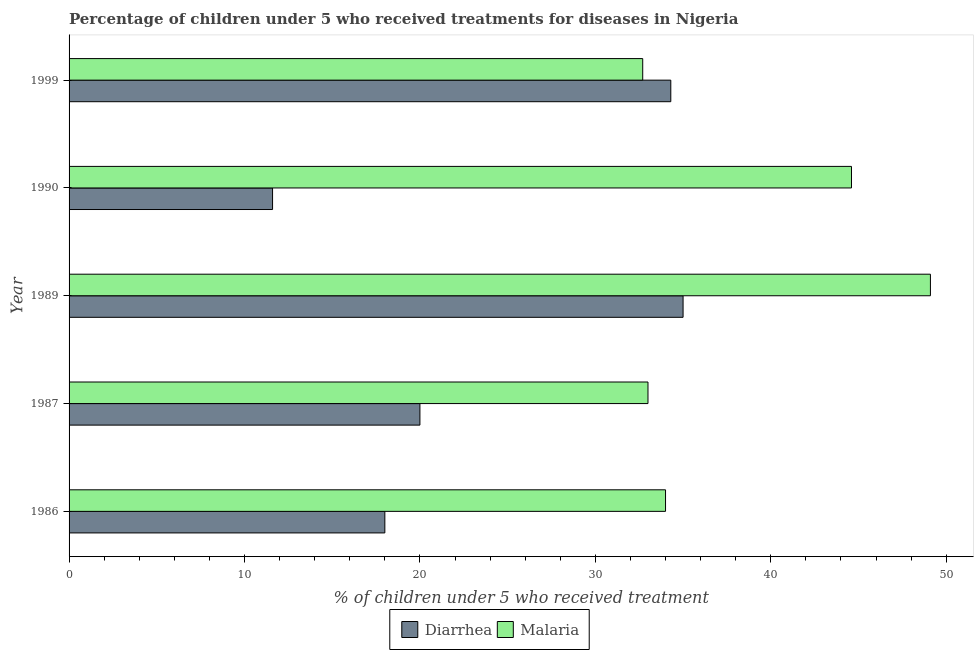How many groups of bars are there?
Provide a short and direct response. 5. How many bars are there on the 5th tick from the top?
Provide a short and direct response. 2. How many bars are there on the 2nd tick from the bottom?
Make the answer very short. 2. What is the label of the 1st group of bars from the top?
Make the answer very short. 1999. What is the percentage of children who received treatment for malaria in 1990?
Your response must be concise. 44.6. Across all years, what is the maximum percentage of children who received treatment for malaria?
Your response must be concise. 49.1. In which year was the percentage of children who received treatment for malaria maximum?
Keep it short and to the point. 1989. What is the total percentage of children who received treatment for malaria in the graph?
Your answer should be compact. 193.4. What is the difference between the percentage of children who received treatment for malaria in 1986 and that in 1989?
Your response must be concise. -15.1. What is the average percentage of children who received treatment for diarrhoea per year?
Your response must be concise. 23.78. In the year 1989, what is the difference between the percentage of children who received treatment for malaria and percentage of children who received treatment for diarrhoea?
Give a very brief answer. 14.1. Is the percentage of children who received treatment for diarrhoea in 1990 less than that in 1999?
Ensure brevity in your answer.  Yes. In how many years, is the percentage of children who received treatment for malaria greater than the average percentage of children who received treatment for malaria taken over all years?
Provide a succinct answer. 2. What does the 1st bar from the top in 1990 represents?
Your answer should be very brief. Malaria. What does the 1st bar from the bottom in 1990 represents?
Your answer should be compact. Diarrhea. Are all the bars in the graph horizontal?
Provide a short and direct response. Yes. Are the values on the major ticks of X-axis written in scientific E-notation?
Keep it short and to the point. No. Does the graph contain grids?
Your answer should be compact. No. How are the legend labels stacked?
Your response must be concise. Horizontal. What is the title of the graph?
Make the answer very short. Percentage of children under 5 who received treatments for diseases in Nigeria. Does "Fertility rate" appear as one of the legend labels in the graph?
Offer a very short reply. No. What is the label or title of the X-axis?
Provide a succinct answer. % of children under 5 who received treatment. What is the label or title of the Y-axis?
Offer a very short reply. Year. What is the % of children under 5 who received treatment of Malaria in 1986?
Your answer should be compact. 34. What is the % of children under 5 who received treatment of Diarrhea in 1989?
Ensure brevity in your answer.  35. What is the % of children under 5 who received treatment of Malaria in 1989?
Keep it short and to the point. 49.1. What is the % of children under 5 who received treatment in Malaria in 1990?
Ensure brevity in your answer.  44.6. What is the % of children under 5 who received treatment in Diarrhea in 1999?
Provide a short and direct response. 34.3. What is the % of children under 5 who received treatment of Malaria in 1999?
Provide a succinct answer. 32.7. Across all years, what is the maximum % of children under 5 who received treatment in Diarrhea?
Offer a terse response. 35. Across all years, what is the maximum % of children under 5 who received treatment of Malaria?
Provide a short and direct response. 49.1. Across all years, what is the minimum % of children under 5 who received treatment in Malaria?
Ensure brevity in your answer.  32.7. What is the total % of children under 5 who received treatment of Diarrhea in the graph?
Make the answer very short. 118.9. What is the total % of children under 5 who received treatment in Malaria in the graph?
Your response must be concise. 193.4. What is the difference between the % of children under 5 who received treatment in Malaria in 1986 and that in 1987?
Provide a succinct answer. 1. What is the difference between the % of children under 5 who received treatment in Malaria in 1986 and that in 1989?
Offer a terse response. -15.1. What is the difference between the % of children under 5 who received treatment in Diarrhea in 1986 and that in 1990?
Offer a terse response. 6.4. What is the difference between the % of children under 5 who received treatment in Malaria in 1986 and that in 1990?
Your answer should be compact. -10.6. What is the difference between the % of children under 5 who received treatment in Diarrhea in 1986 and that in 1999?
Ensure brevity in your answer.  -16.3. What is the difference between the % of children under 5 who received treatment of Malaria in 1986 and that in 1999?
Provide a succinct answer. 1.3. What is the difference between the % of children under 5 who received treatment of Malaria in 1987 and that in 1989?
Your answer should be very brief. -16.1. What is the difference between the % of children under 5 who received treatment of Diarrhea in 1987 and that in 1990?
Ensure brevity in your answer.  8.4. What is the difference between the % of children under 5 who received treatment in Diarrhea in 1987 and that in 1999?
Provide a succinct answer. -14.3. What is the difference between the % of children under 5 who received treatment in Malaria in 1987 and that in 1999?
Provide a succinct answer. 0.3. What is the difference between the % of children under 5 who received treatment of Diarrhea in 1989 and that in 1990?
Keep it short and to the point. 23.4. What is the difference between the % of children under 5 who received treatment in Malaria in 1989 and that in 1990?
Keep it short and to the point. 4.5. What is the difference between the % of children under 5 who received treatment in Diarrhea in 1989 and that in 1999?
Keep it short and to the point. 0.7. What is the difference between the % of children under 5 who received treatment in Malaria in 1989 and that in 1999?
Your answer should be very brief. 16.4. What is the difference between the % of children under 5 who received treatment in Diarrhea in 1990 and that in 1999?
Give a very brief answer. -22.7. What is the difference between the % of children under 5 who received treatment of Malaria in 1990 and that in 1999?
Offer a very short reply. 11.9. What is the difference between the % of children under 5 who received treatment in Diarrhea in 1986 and the % of children under 5 who received treatment in Malaria in 1989?
Keep it short and to the point. -31.1. What is the difference between the % of children under 5 who received treatment of Diarrhea in 1986 and the % of children under 5 who received treatment of Malaria in 1990?
Keep it short and to the point. -26.6. What is the difference between the % of children under 5 who received treatment in Diarrhea in 1986 and the % of children under 5 who received treatment in Malaria in 1999?
Give a very brief answer. -14.7. What is the difference between the % of children under 5 who received treatment in Diarrhea in 1987 and the % of children under 5 who received treatment in Malaria in 1989?
Offer a very short reply. -29.1. What is the difference between the % of children under 5 who received treatment in Diarrhea in 1987 and the % of children under 5 who received treatment in Malaria in 1990?
Give a very brief answer. -24.6. What is the difference between the % of children under 5 who received treatment of Diarrhea in 1990 and the % of children under 5 who received treatment of Malaria in 1999?
Provide a succinct answer. -21.1. What is the average % of children under 5 who received treatment of Diarrhea per year?
Your answer should be compact. 23.78. What is the average % of children under 5 who received treatment of Malaria per year?
Ensure brevity in your answer.  38.68. In the year 1989, what is the difference between the % of children under 5 who received treatment of Diarrhea and % of children under 5 who received treatment of Malaria?
Your answer should be very brief. -14.1. In the year 1990, what is the difference between the % of children under 5 who received treatment of Diarrhea and % of children under 5 who received treatment of Malaria?
Ensure brevity in your answer.  -33. In the year 1999, what is the difference between the % of children under 5 who received treatment of Diarrhea and % of children under 5 who received treatment of Malaria?
Give a very brief answer. 1.6. What is the ratio of the % of children under 5 who received treatment in Diarrhea in 1986 to that in 1987?
Keep it short and to the point. 0.9. What is the ratio of the % of children under 5 who received treatment in Malaria in 1986 to that in 1987?
Provide a short and direct response. 1.03. What is the ratio of the % of children under 5 who received treatment in Diarrhea in 1986 to that in 1989?
Give a very brief answer. 0.51. What is the ratio of the % of children under 5 who received treatment in Malaria in 1986 to that in 1989?
Provide a short and direct response. 0.69. What is the ratio of the % of children under 5 who received treatment of Diarrhea in 1986 to that in 1990?
Make the answer very short. 1.55. What is the ratio of the % of children under 5 who received treatment in Malaria in 1986 to that in 1990?
Provide a short and direct response. 0.76. What is the ratio of the % of children under 5 who received treatment of Diarrhea in 1986 to that in 1999?
Offer a terse response. 0.52. What is the ratio of the % of children under 5 who received treatment of Malaria in 1986 to that in 1999?
Offer a terse response. 1.04. What is the ratio of the % of children under 5 who received treatment of Diarrhea in 1987 to that in 1989?
Your answer should be very brief. 0.57. What is the ratio of the % of children under 5 who received treatment of Malaria in 1987 to that in 1989?
Keep it short and to the point. 0.67. What is the ratio of the % of children under 5 who received treatment in Diarrhea in 1987 to that in 1990?
Provide a short and direct response. 1.72. What is the ratio of the % of children under 5 who received treatment of Malaria in 1987 to that in 1990?
Offer a very short reply. 0.74. What is the ratio of the % of children under 5 who received treatment in Diarrhea in 1987 to that in 1999?
Your response must be concise. 0.58. What is the ratio of the % of children under 5 who received treatment in Malaria in 1987 to that in 1999?
Offer a very short reply. 1.01. What is the ratio of the % of children under 5 who received treatment in Diarrhea in 1989 to that in 1990?
Provide a succinct answer. 3.02. What is the ratio of the % of children under 5 who received treatment of Malaria in 1989 to that in 1990?
Your answer should be compact. 1.1. What is the ratio of the % of children under 5 who received treatment in Diarrhea in 1989 to that in 1999?
Ensure brevity in your answer.  1.02. What is the ratio of the % of children under 5 who received treatment in Malaria in 1989 to that in 1999?
Ensure brevity in your answer.  1.5. What is the ratio of the % of children under 5 who received treatment of Diarrhea in 1990 to that in 1999?
Your response must be concise. 0.34. What is the ratio of the % of children under 5 who received treatment of Malaria in 1990 to that in 1999?
Keep it short and to the point. 1.36. What is the difference between the highest and the second highest % of children under 5 who received treatment of Malaria?
Your answer should be very brief. 4.5. What is the difference between the highest and the lowest % of children under 5 who received treatment in Diarrhea?
Give a very brief answer. 23.4. 